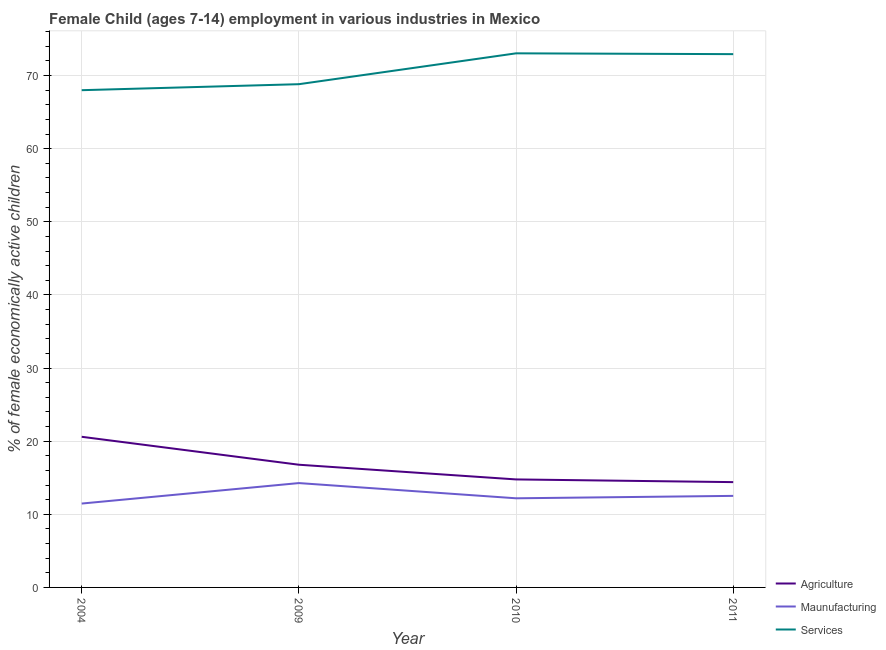Is the number of lines equal to the number of legend labels?
Your response must be concise. Yes. What is the percentage of economically active children in manufacturing in 2010?
Ensure brevity in your answer.  12.19. Across all years, what is the maximum percentage of economically active children in agriculture?
Provide a short and direct response. 20.6. In which year was the percentage of economically active children in manufacturing minimum?
Your response must be concise. 2004. What is the total percentage of economically active children in agriculture in the graph?
Keep it short and to the point. 66.55. What is the difference between the percentage of economically active children in manufacturing in 2010 and that in 2011?
Your answer should be compact. -0.33. What is the difference between the percentage of economically active children in agriculture in 2011 and the percentage of economically active children in services in 2004?
Your answer should be very brief. -53.6. What is the average percentage of economically active children in agriculture per year?
Make the answer very short. 16.64. In the year 2011, what is the difference between the percentage of economically active children in services and percentage of economically active children in agriculture?
Give a very brief answer. 58.53. What is the ratio of the percentage of economically active children in manufacturing in 2009 to that in 2010?
Give a very brief answer. 1.17. Is the difference between the percentage of economically active children in agriculture in 2004 and 2010 greater than the difference between the percentage of economically active children in services in 2004 and 2010?
Your answer should be compact. Yes. What is the difference between the highest and the second highest percentage of economically active children in services?
Your answer should be very brief. 0.11. What is the difference between the highest and the lowest percentage of economically active children in agriculture?
Offer a very short reply. 6.2. How many lines are there?
Provide a succinct answer. 3. What is the difference between two consecutive major ticks on the Y-axis?
Keep it short and to the point. 10. Does the graph contain any zero values?
Provide a succinct answer. No. Does the graph contain grids?
Provide a succinct answer. Yes. What is the title of the graph?
Your answer should be very brief. Female Child (ages 7-14) employment in various industries in Mexico. Does "Solid fuel" appear as one of the legend labels in the graph?
Provide a short and direct response. No. What is the label or title of the X-axis?
Provide a short and direct response. Year. What is the label or title of the Y-axis?
Keep it short and to the point. % of female economically active children. What is the % of female economically active children in Agriculture in 2004?
Ensure brevity in your answer.  20.6. What is the % of female economically active children in Maunufacturing in 2004?
Provide a succinct answer. 11.47. What is the % of female economically active children in Services in 2004?
Your answer should be very brief. 68. What is the % of female economically active children of Agriculture in 2009?
Make the answer very short. 16.78. What is the % of female economically active children of Maunufacturing in 2009?
Your response must be concise. 14.27. What is the % of female economically active children of Services in 2009?
Your response must be concise. 68.82. What is the % of female economically active children in Agriculture in 2010?
Make the answer very short. 14.77. What is the % of female economically active children of Maunufacturing in 2010?
Your answer should be compact. 12.19. What is the % of female economically active children in Services in 2010?
Make the answer very short. 73.04. What is the % of female economically active children of Maunufacturing in 2011?
Your answer should be compact. 12.52. What is the % of female economically active children in Services in 2011?
Provide a short and direct response. 72.93. Across all years, what is the maximum % of female economically active children in Agriculture?
Provide a succinct answer. 20.6. Across all years, what is the maximum % of female economically active children of Maunufacturing?
Provide a succinct answer. 14.27. Across all years, what is the maximum % of female economically active children of Services?
Provide a succinct answer. 73.04. Across all years, what is the minimum % of female economically active children in Maunufacturing?
Your answer should be compact. 11.47. What is the total % of female economically active children of Agriculture in the graph?
Offer a terse response. 66.55. What is the total % of female economically active children of Maunufacturing in the graph?
Make the answer very short. 50.45. What is the total % of female economically active children in Services in the graph?
Provide a succinct answer. 282.79. What is the difference between the % of female economically active children of Agriculture in 2004 and that in 2009?
Your answer should be very brief. 3.82. What is the difference between the % of female economically active children of Maunufacturing in 2004 and that in 2009?
Provide a short and direct response. -2.8. What is the difference between the % of female economically active children in Services in 2004 and that in 2009?
Give a very brief answer. -0.82. What is the difference between the % of female economically active children in Agriculture in 2004 and that in 2010?
Your response must be concise. 5.83. What is the difference between the % of female economically active children of Maunufacturing in 2004 and that in 2010?
Make the answer very short. -0.72. What is the difference between the % of female economically active children of Services in 2004 and that in 2010?
Ensure brevity in your answer.  -5.04. What is the difference between the % of female economically active children in Agriculture in 2004 and that in 2011?
Your response must be concise. 6.2. What is the difference between the % of female economically active children in Maunufacturing in 2004 and that in 2011?
Your answer should be compact. -1.05. What is the difference between the % of female economically active children in Services in 2004 and that in 2011?
Offer a very short reply. -4.93. What is the difference between the % of female economically active children in Agriculture in 2009 and that in 2010?
Provide a short and direct response. 2.01. What is the difference between the % of female economically active children of Maunufacturing in 2009 and that in 2010?
Ensure brevity in your answer.  2.08. What is the difference between the % of female economically active children in Services in 2009 and that in 2010?
Offer a very short reply. -4.22. What is the difference between the % of female economically active children of Agriculture in 2009 and that in 2011?
Your response must be concise. 2.38. What is the difference between the % of female economically active children of Maunufacturing in 2009 and that in 2011?
Make the answer very short. 1.75. What is the difference between the % of female economically active children of Services in 2009 and that in 2011?
Provide a short and direct response. -4.11. What is the difference between the % of female economically active children of Agriculture in 2010 and that in 2011?
Give a very brief answer. 0.37. What is the difference between the % of female economically active children in Maunufacturing in 2010 and that in 2011?
Provide a succinct answer. -0.33. What is the difference between the % of female economically active children of Services in 2010 and that in 2011?
Ensure brevity in your answer.  0.11. What is the difference between the % of female economically active children in Agriculture in 2004 and the % of female economically active children in Maunufacturing in 2009?
Your answer should be compact. 6.33. What is the difference between the % of female economically active children in Agriculture in 2004 and the % of female economically active children in Services in 2009?
Your response must be concise. -48.22. What is the difference between the % of female economically active children of Maunufacturing in 2004 and the % of female economically active children of Services in 2009?
Provide a succinct answer. -57.35. What is the difference between the % of female economically active children of Agriculture in 2004 and the % of female economically active children of Maunufacturing in 2010?
Give a very brief answer. 8.41. What is the difference between the % of female economically active children of Agriculture in 2004 and the % of female economically active children of Services in 2010?
Keep it short and to the point. -52.44. What is the difference between the % of female economically active children of Maunufacturing in 2004 and the % of female economically active children of Services in 2010?
Your answer should be very brief. -61.57. What is the difference between the % of female economically active children in Agriculture in 2004 and the % of female economically active children in Maunufacturing in 2011?
Your answer should be very brief. 8.08. What is the difference between the % of female economically active children in Agriculture in 2004 and the % of female economically active children in Services in 2011?
Provide a short and direct response. -52.33. What is the difference between the % of female economically active children of Maunufacturing in 2004 and the % of female economically active children of Services in 2011?
Your response must be concise. -61.46. What is the difference between the % of female economically active children in Agriculture in 2009 and the % of female economically active children in Maunufacturing in 2010?
Offer a terse response. 4.59. What is the difference between the % of female economically active children of Agriculture in 2009 and the % of female economically active children of Services in 2010?
Make the answer very short. -56.26. What is the difference between the % of female economically active children in Maunufacturing in 2009 and the % of female economically active children in Services in 2010?
Ensure brevity in your answer.  -58.77. What is the difference between the % of female economically active children in Agriculture in 2009 and the % of female economically active children in Maunufacturing in 2011?
Offer a very short reply. 4.26. What is the difference between the % of female economically active children in Agriculture in 2009 and the % of female economically active children in Services in 2011?
Provide a short and direct response. -56.15. What is the difference between the % of female economically active children of Maunufacturing in 2009 and the % of female economically active children of Services in 2011?
Provide a short and direct response. -58.66. What is the difference between the % of female economically active children of Agriculture in 2010 and the % of female economically active children of Maunufacturing in 2011?
Make the answer very short. 2.25. What is the difference between the % of female economically active children of Agriculture in 2010 and the % of female economically active children of Services in 2011?
Provide a short and direct response. -58.16. What is the difference between the % of female economically active children in Maunufacturing in 2010 and the % of female economically active children in Services in 2011?
Offer a very short reply. -60.74. What is the average % of female economically active children in Agriculture per year?
Your answer should be very brief. 16.64. What is the average % of female economically active children of Maunufacturing per year?
Your answer should be very brief. 12.61. What is the average % of female economically active children of Services per year?
Give a very brief answer. 70.7. In the year 2004, what is the difference between the % of female economically active children of Agriculture and % of female economically active children of Maunufacturing?
Ensure brevity in your answer.  9.13. In the year 2004, what is the difference between the % of female economically active children of Agriculture and % of female economically active children of Services?
Give a very brief answer. -47.4. In the year 2004, what is the difference between the % of female economically active children in Maunufacturing and % of female economically active children in Services?
Make the answer very short. -56.53. In the year 2009, what is the difference between the % of female economically active children of Agriculture and % of female economically active children of Maunufacturing?
Ensure brevity in your answer.  2.51. In the year 2009, what is the difference between the % of female economically active children in Agriculture and % of female economically active children in Services?
Your answer should be very brief. -52.04. In the year 2009, what is the difference between the % of female economically active children in Maunufacturing and % of female economically active children in Services?
Keep it short and to the point. -54.55. In the year 2010, what is the difference between the % of female economically active children of Agriculture and % of female economically active children of Maunufacturing?
Provide a succinct answer. 2.58. In the year 2010, what is the difference between the % of female economically active children in Agriculture and % of female economically active children in Services?
Provide a short and direct response. -58.27. In the year 2010, what is the difference between the % of female economically active children in Maunufacturing and % of female economically active children in Services?
Ensure brevity in your answer.  -60.85. In the year 2011, what is the difference between the % of female economically active children of Agriculture and % of female economically active children of Maunufacturing?
Keep it short and to the point. 1.88. In the year 2011, what is the difference between the % of female economically active children in Agriculture and % of female economically active children in Services?
Offer a terse response. -58.53. In the year 2011, what is the difference between the % of female economically active children of Maunufacturing and % of female economically active children of Services?
Offer a terse response. -60.41. What is the ratio of the % of female economically active children in Agriculture in 2004 to that in 2009?
Provide a succinct answer. 1.23. What is the ratio of the % of female economically active children of Maunufacturing in 2004 to that in 2009?
Offer a terse response. 0.8. What is the ratio of the % of female economically active children of Services in 2004 to that in 2009?
Offer a terse response. 0.99. What is the ratio of the % of female economically active children in Agriculture in 2004 to that in 2010?
Offer a terse response. 1.39. What is the ratio of the % of female economically active children of Maunufacturing in 2004 to that in 2010?
Make the answer very short. 0.94. What is the ratio of the % of female economically active children in Agriculture in 2004 to that in 2011?
Give a very brief answer. 1.43. What is the ratio of the % of female economically active children of Maunufacturing in 2004 to that in 2011?
Offer a very short reply. 0.92. What is the ratio of the % of female economically active children of Services in 2004 to that in 2011?
Provide a short and direct response. 0.93. What is the ratio of the % of female economically active children in Agriculture in 2009 to that in 2010?
Your answer should be compact. 1.14. What is the ratio of the % of female economically active children of Maunufacturing in 2009 to that in 2010?
Provide a short and direct response. 1.17. What is the ratio of the % of female economically active children in Services in 2009 to that in 2010?
Offer a terse response. 0.94. What is the ratio of the % of female economically active children of Agriculture in 2009 to that in 2011?
Offer a terse response. 1.17. What is the ratio of the % of female economically active children of Maunufacturing in 2009 to that in 2011?
Provide a short and direct response. 1.14. What is the ratio of the % of female economically active children of Services in 2009 to that in 2011?
Your response must be concise. 0.94. What is the ratio of the % of female economically active children of Agriculture in 2010 to that in 2011?
Provide a short and direct response. 1.03. What is the ratio of the % of female economically active children of Maunufacturing in 2010 to that in 2011?
Offer a terse response. 0.97. What is the difference between the highest and the second highest % of female economically active children of Agriculture?
Offer a very short reply. 3.82. What is the difference between the highest and the second highest % of female economically active children in Maunufacturing?
Your answer should be very brief. 1.75. What is the difference between the highest and the second highest % of female economically active children of Services?
Give a very brief answer. 0.11. What is the difference between the highest and the lowest % of female economically active children of Agriculture?
Make the answer very short. 6.2. What is the difference between the highest and the lowest % of female economically active children of Services?
Provide a succinct answer. 5.04. 